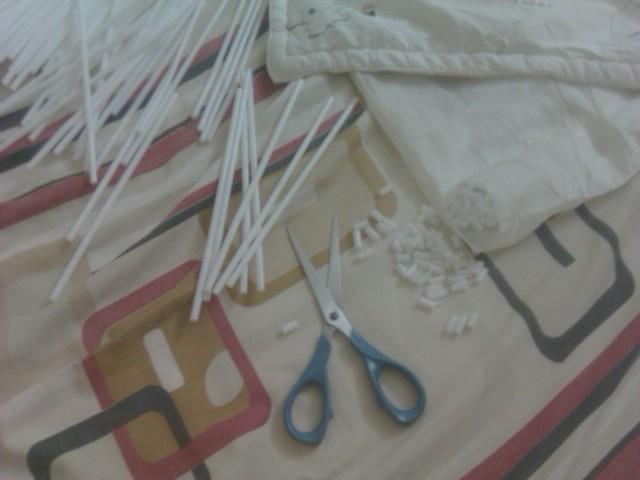How many airplanes do you see?
Give a very brief answer. 0. 